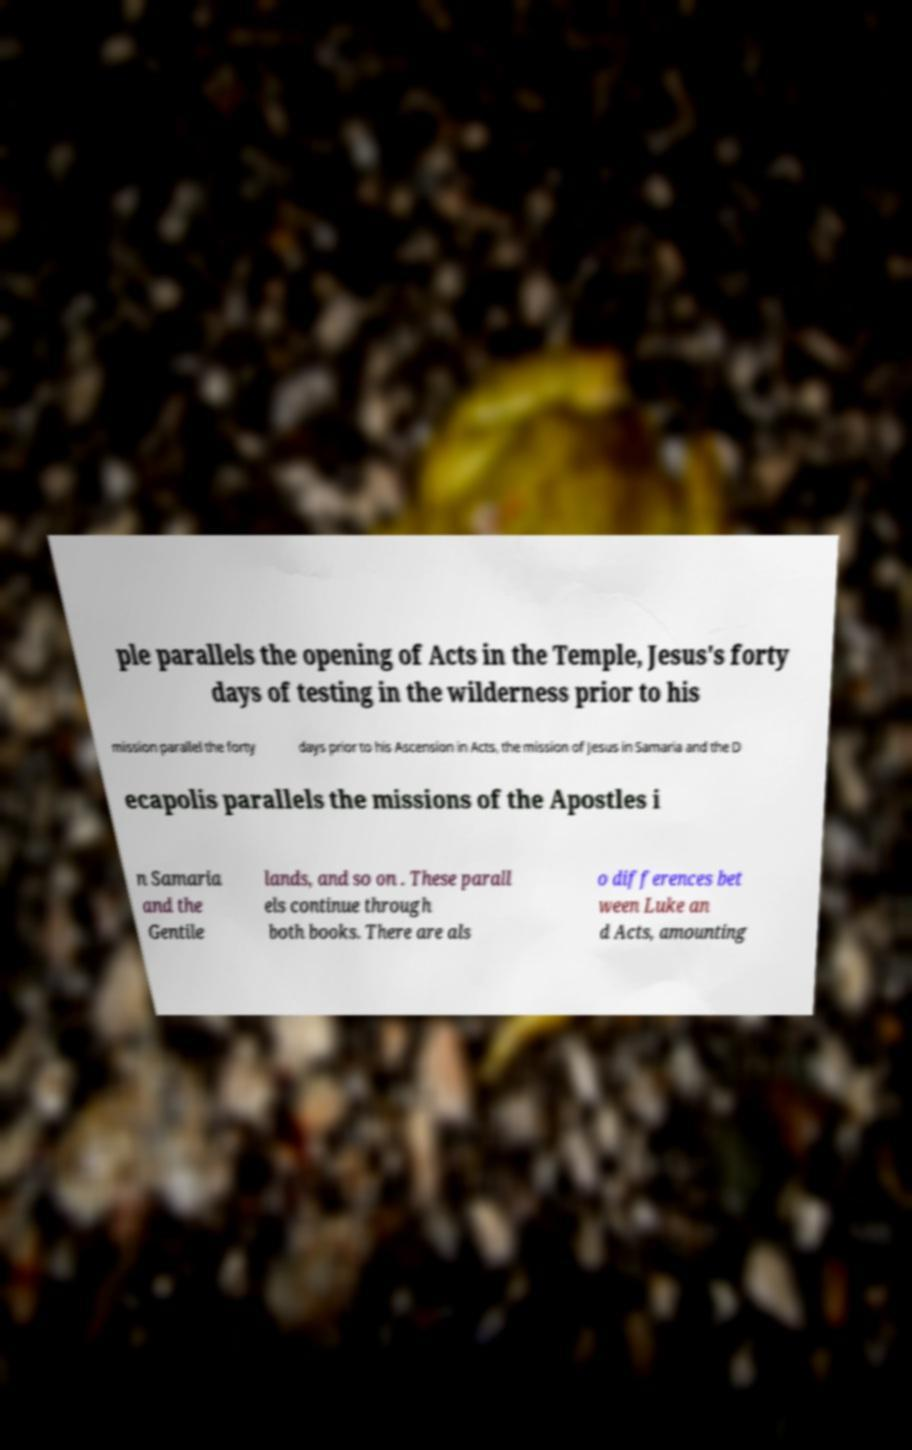Please identify and transcribe the text found in this image. ple parallels the opening of Acts in the Temple, Jesus's forty days of testing in the wilderness prior to his mission parallel the forty days prior to his Ascension in Acts, the mission of Jesus in Samaria and the D ecapolis parallels the missions of the Apostles i n Samaria and the Gentile lands, and so on . These parall els continue through both books. There are als o differences bet ween Luke an d Acts, amounting 